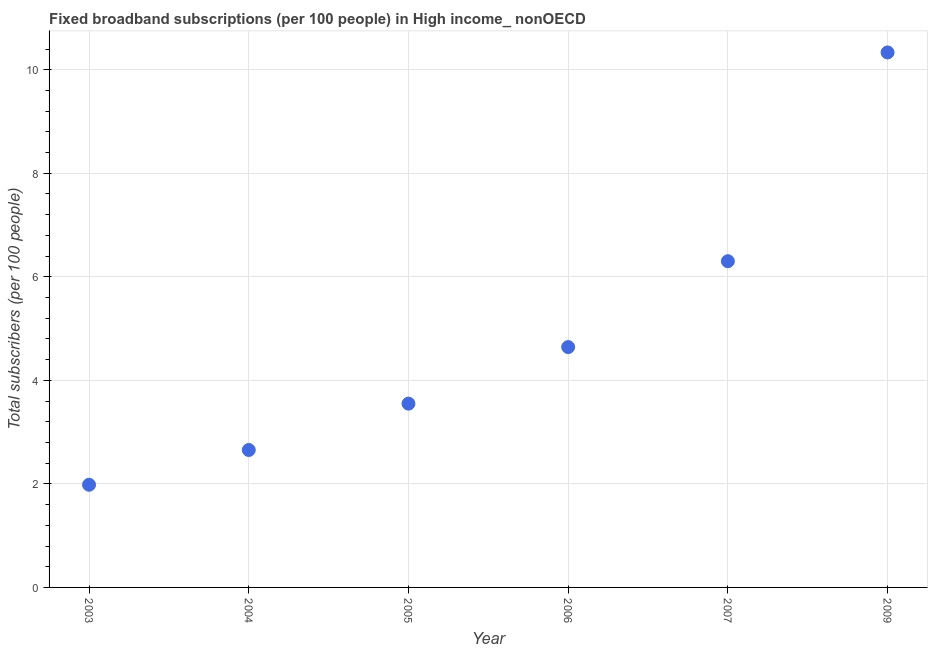What is the total number of fixed broadband subscriptions in 2009?
Provide a succinct answer. 10.33. Across all years, what is the maximum total number of fixed broadband subscriptions?
Give a very brief answer. 10.33. Across all years, what is the minimum total number of fixed broadband subscriptions?
Your answer should be very brief. 1.98. In which year was the total number of fixed broadband subscriptions maximum?
Your answer should be compact. 2009. What is the sum of the total number of fixed broadband subscriptions?
Provide a short and direct response. 29.47. What is the difference between the total number of fixed broadband subscriptions in 2003 and 2007?
Your answer should be compact. -4.32. What is the average total number of fixed broadband subscriptions per year?
Offer a very short reply. 4.91. What is the median total number of fixed broadband subscriptions?
Offer a terse response. 4.1. In how many years, is the total number of fixed broadband subscriptions greater than 0.4 ?
Make the answer very short. 6. What is the ratio of the total number of fixed broadband subscriptions in 2005 to that in 2009?
Provide a succinct answer. 0.34. Is the total number of fixed broadband subscriptions in 2003 less than that in 2009?
Give a very brief answer. Yes. What is the difference between the highest and the second highest total number of fixed broadband subscriptions?
Provide a succinct answer. 4.03. Is the sum of the total number of fixed broadband subscriptions in 2003 and 2005 greater than the maximum total number of fixed broadband subscriptions across all years?
Give a very brief answer. No. What is the difference between the highest and the lowest total number of fixed broadband subscriptions?
Ensure brevity in your answer.  8.35. Does the total number of fixed broadband subscriptions monotonically increase over the years?
Provide a succinct answer. Yes. How many dotlines are there?
Offer a very short reply. 1. What is the difference between two consecutive major ticks on the Y-axis?
Provide a succinct answer. 2. Are the values on the major ticks of Y-axis written in scientific E-notation?
Keep it short and to the point. No. Does the graph contain grids?
Make the answer very short. Yes. What is the title of the graph?
Provide a short and direct response. Fixed broadband subscriptions (per 100 people) in High income_ nonOECD. What is the label or title of the X-axis?
Keep it short and to the point. Year. What is the label or title of the Y-axis?
Provide a succinct answer. Total subscribers (per 100 people). What is the Total subscribers (per 100 people) in 2003?
Keep it short and to the point. 1.98. What is the Total subscribers (per 100 people) in 2004?
Ensure brevity in your answer.  2.66. What is the Total subscribers (per 100 people) in 2005?
Provide a succinct answer. 3.55. What is the Total subscribers (per 100 people) in 2006?
Keep it short and to the point. 4.64. What is the Total subscribers (per 100 people) in 2007?
Offer a very short reply. 6.3. What is the Total subscribers (per 100 people) in 2009?
Offer a terse response. 10.33. What is the difference between the Total subscribers (per 100 people) in 2003 and 2004?
Offer a terse response. -0.67. What is the difference between the Total subscribers (per 100 people) in 2003 and 2005?
Provide a succinct answer. -1.57. What is the difference between the Total subscribers (per 100 people) in 2003 and 2006?
Your answer should be compact. -2.66. What is the difference between the Total subscribers (per 100 people) in 2003 and 2007?
Provide a short and direct response. -4.32. What is the difference between the Total subscribers (per 100 people) in 2003 and 2009?
Your answer should be compact. -8.35. What is the difference between the Total subscribers (per 100 people) in 2004 and 2005?
Provide a short and direct response. -0.89. What is the difference between the Total subscribers (per 100 people) in 2004 and 2006?
Keep it short and to the point. -1.99. What is the difference between the Total subscribers (per 100 people) in 2004 and 2007?
Your response must be concise. -3.65. What is the difference between the Total subscribers (per 100 people) in 2004 and 2009?
Provide a short and direct response. -7.68. What is the difference between the Total subscribers (per 100 people) in 2005 and 2006?
Your answer should be very brief. -1.09. What is the difference between the Total subscribers (per 100 people) in 2005 and 2007?
Give a very brief answer. -2.75. What is the difference between the Total subscribers (per 100 people) in 2005 and 2009?
Ensure brevity in your answer.  -6.78. What is the difference between the Total subscribers (per 100 people) in 2006 and 2007?
Keep it short and to the point. -1.66. What is the difference between the Total subscribers (per 100 people) in 2006 and 2009?
Keep it short and to the point. -5.69. What is the difference between the Total subscribers (per 100 people) in 2007 and 2009?
Give a very brief answer. -4.03. What is the ratio of the Total subscribers (per 100 people) in 2003 to that in 2004?
Keep it short and to the point. 0.75. What is the ratio of the Total subscribers (per 100 people) in 2003 to that in 2005?
Ensure brevity in your answer.  0.56. What is the ratio of the Total subscribers (per 100 people) in 2003 to that in 2006?
Your response must be concise. 0.43. What is the ratio of the Total subscribers (per 100 people) in 2003 to that in 2007?
Provide a succinct answer. 0.32. What is the ratio of the Total subscribers (per 100 people) in 2003 to that in 2009?
Offer a terse response. 0.19. What is the ratio of the Total subscribers (per 100 people) in 2004 to that in 2005?
Provide a short and direct response. 0.75. What is the ratio of the Total subscribers (per 100 people) in 2004 to that in 2006?
Provide a succinct answer. 0.57. What is the ratio of the Total subscribers (per 100 people) in 2004 to that in 2007?
Make the answer very short. 0.42. What is the ratio of the Total subscribers (per 100 people) in 2004 to that in 2009?
Make the answer very short. 0.26. What is the ratio of the Total subscribers (per 100 people) in 2005 to that in 2006?
Offer a terse response. 0.77. What is the ratio of the Total subscribers (per 100 people) in 2005 to that in 2007?
Ensure brevity in your answer.  0.56. What is the ratio of the Total subscribers (per 100 people) in 2005 to that in 2009?
Ensure brevity in your answer.  0.34. What is the ratio of the Total subscribers (per 100 people) in 2006 to that in 2007?
Your response must be concise. 0.74. What is the ratio of the Total subscribers (per 100 people) in 2006 to that in 2009?
Your answer should be compact. 0.45. What is the ratio of the Total subscribers (per 100 people) in 2007 to that in 2009?
Offer a terse response. 0.61. 